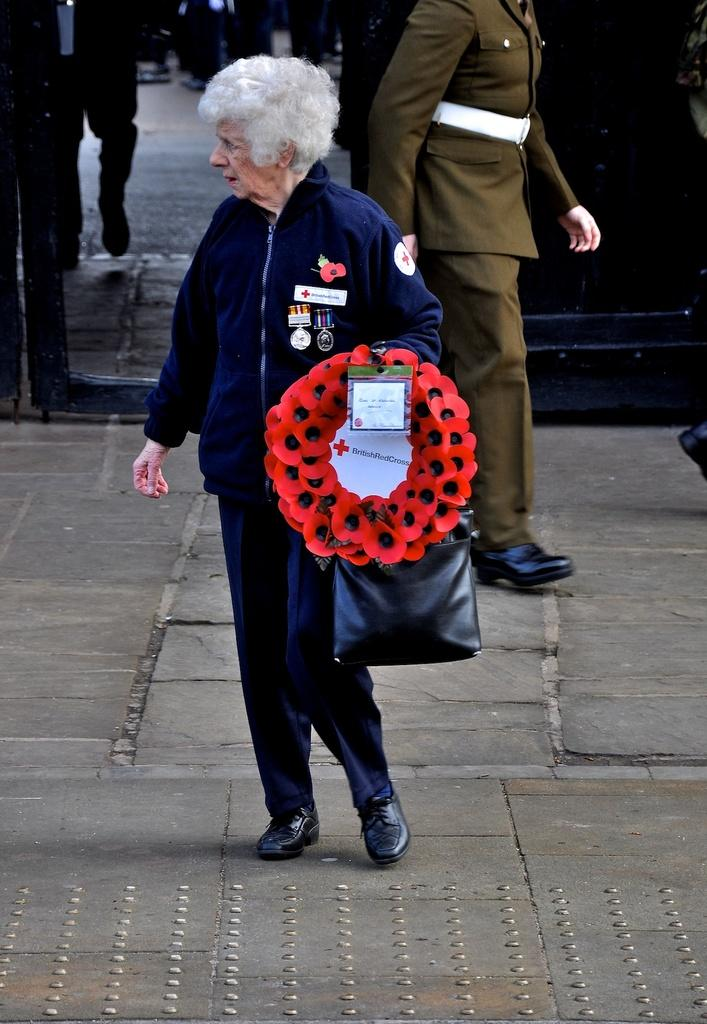What is the person in the image holding? The person in the image is holding a bag. What else is the person holding besides the bag? There is an object being held by the person, but the specific object is not mentioned in the facts. Can you describe the people in the background of the image? There are two persons in the background of the image, but their appearance or actions are not mentioned in the facts. What type of plants can be seen growing on the person's elbow in the image? There is no mention of plants or elbows in the image, so it is not possible to answer that question. 